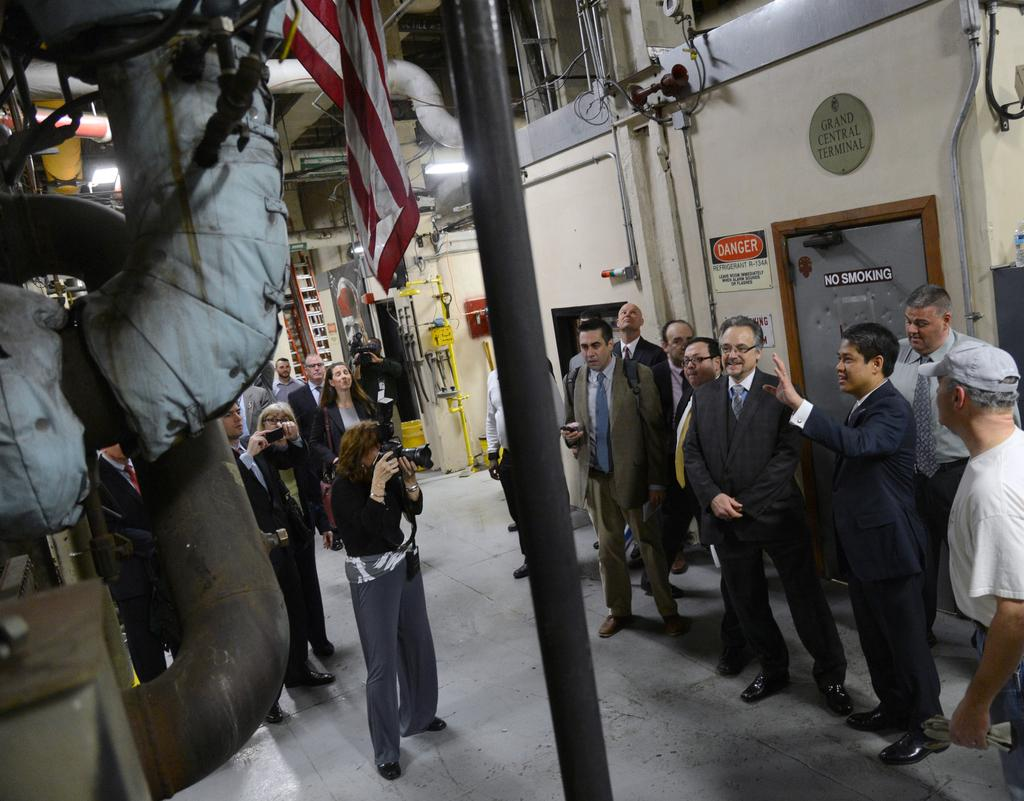How many people are in the image? There is a group of people standing in the image. What are two of the people holding? Two persons are holding cameras. What can be seen in the image that represents a symbol or country? There is a flag in the image. What type of structures can be seen in the image? There are pipes and boards in the image. What can be seen in the image that provides illumination? There are lights in the image. Can you describe any other objects in the image? There are other unspecified objects in the image. What type of duck can be seen playing with a match in the image? There is no duck or match present in the image. Can you describe the bat that is flying in the image? There is no bat present in the image. 